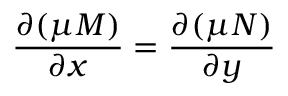Convert formula to latex. <formula><loc_0><loc_0><loc_500><loc_500>{ \frac { \partial ( \mu M ) } { \partial x } } = { \frac { \partial ( \mu N ) } { \partial y } } \,</formula> 